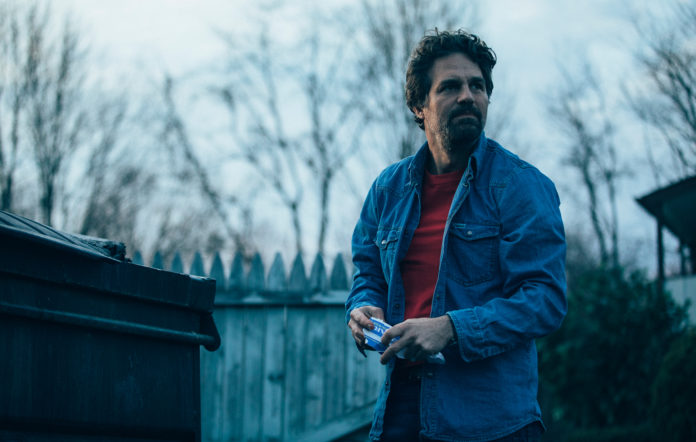Can you provide more context about this image? What might be happening here? It appears that the man is in a suburban setting, perhaps in the backyard or near an alleyway. He seems to be preoccupied, maybe looking at something or someone in the distance. The serious expression and stance suggest he might be meeting someone or waiting for something important. The presence of a dumpster might indicate that he's in a less frequented part of the neighborhood, possibly dealing with a personal matter or overseeing a situation. Could you tell a story based on this image? Sure! John had always taken his evening walks through his quiet neighborhood to clear his head. On this particular evening, the sky was overcast, and the chill of the approaching night wrapped around him like an old friend. As he walked past the familiar picket fence and the dumpsters lining the alleyway, he heard a faint sound that made him stop in his tracks. It was a whisper, so soft it could have been the wind, but it was enough to make the hairs on the back of his neck stand up. He turned, holding his phone tightly in his hand, ready to record any evidence of the strange occurrences. His eyes scanned the treeline beyond the fence, searching for the source of the sound. What he saw next would change everything he thought he knew about his neighborhood. 